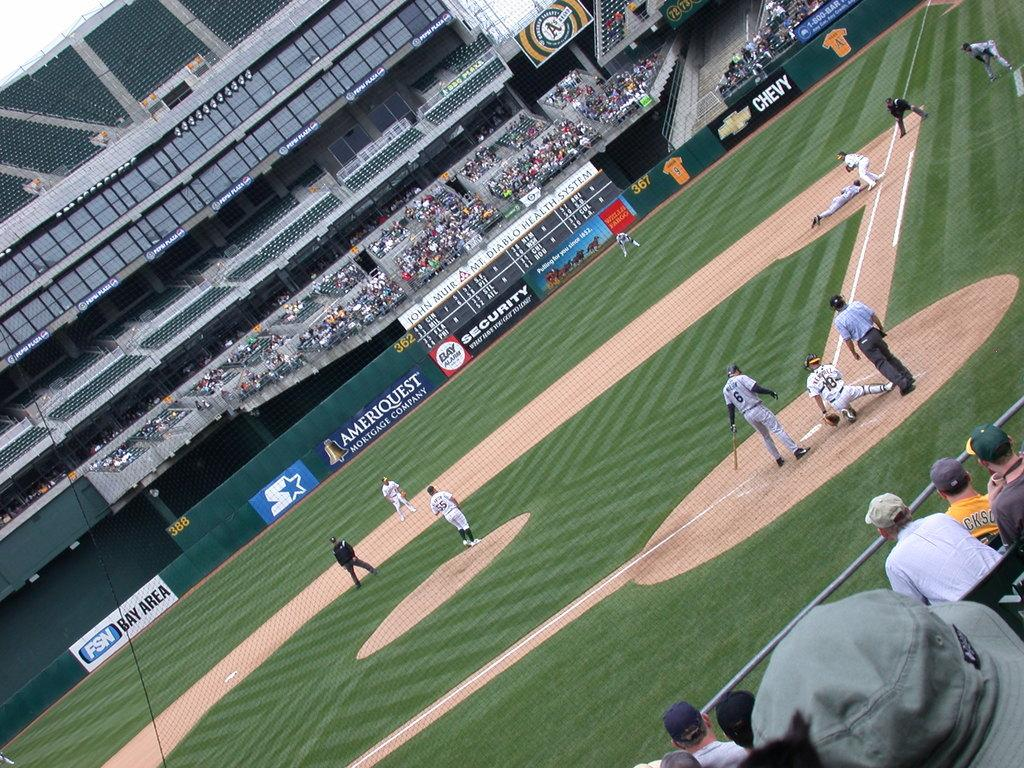Provide a one-sentence caption for the provided image. Baseball Stadium with a sponsor board Ameriquest on green background. 